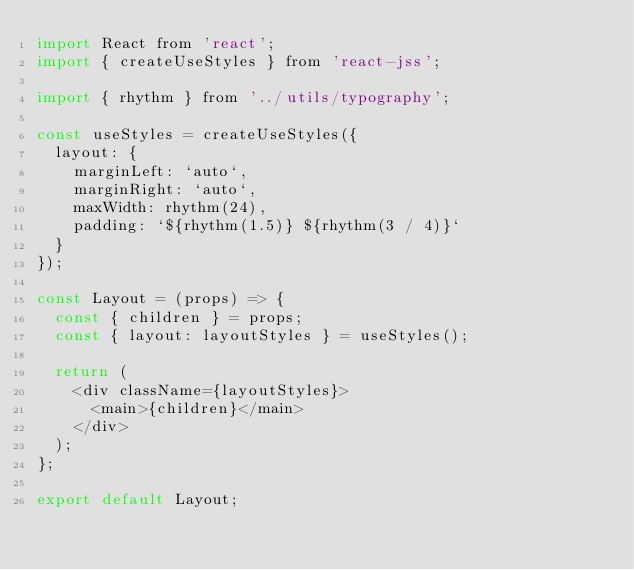Convert code to text. <code><loc_0><loc_0><loc_500><loc_500><_JavaScript_>import React from 'react';
import { createUseStyles } from 'react-jss';

import { rhythm } from '../utils/typography';

const useStyles = createUseStyles({
  layout: {
    marginLeft: `auto`,
    marginRight: `auto`,
    maxWidth: rhythm(24),
    padding: `${rhythm(1.5)} ${rhythm(3 / 4)}`
  }
});

const Layout = (props) => {
  const { children } = props;
  const { layout: layoutStyles } = useStyles();

  return (
    <div className={layoutStyles}>
      <main>{children}</main>
    </div>
  );
};

export default Layout;
</code> 